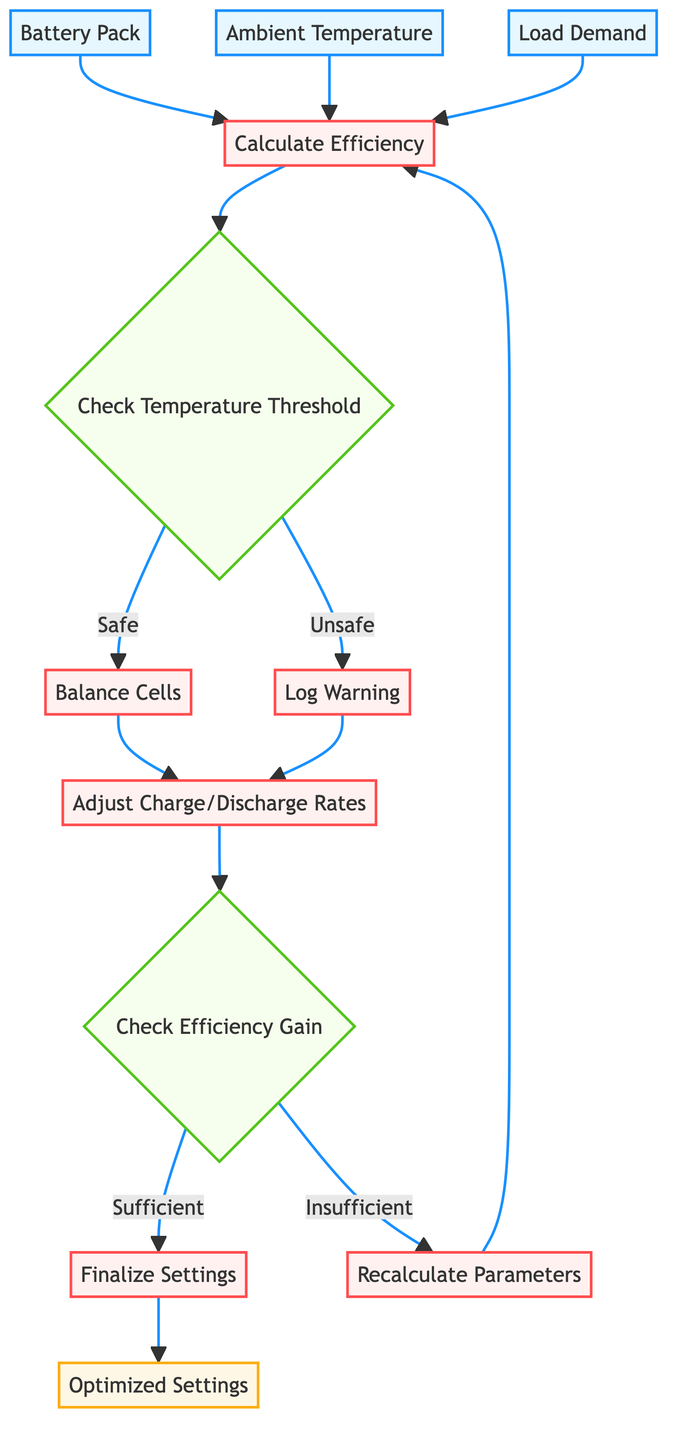What are the three input parameters of the function? The flowchart specifies three input parameters: battery_pack, ambient_temperature, and load_demand.
Answer: battery_pack, ambient_temperature, load_demand Which operation follows the decision node that checks the temperature threshold? After checking the temperature threshold, if the condition is safe, the flowchart directs to the "Balance Cells" operation.
Answer: Balance Cells How many decision nodes are present in the flowchart? There are two decision nodes in the flowchart: "Check Temperature Threshold" and "Check Efficiency Gain."
Answer: 2 What occurs if the efficiency gain is insufficient? If the efficiency gain is insufficient, the flowchart leads to the "Recalculate Parameters" operation to attempt further adjustments.
Answer: Recalculate Parameters What is the final output of the function? The final output of the function as displayed in the flowchart is "Optimized Settings," which represents the settings adjusted for the Battery Management System.
Answer: Optimized Settings How does the flowchart handle unsafe temperature conditions? When the temperature is unsafe, the flowchart directs to the "Log Warning" operation, which indicates a precautionary measure is taken.
Answer: Log Warning What operation is performed after cell balancing? After cell balancing, the next operation performed is "Adjust Charge/Discharge Rates" based on the calculated efficiency and load demand.
Answer: Adjust Charge/Discharge Rates What happens after the efficiency is checked for gain? After checking for efficiency gain, if the gain is sufficient, the flowchart progresses to "Finalize Settings"; otherwise, it loops back to "Recalculate Parameters."
Answer: Finalize Settings or Recalculate Parameters 